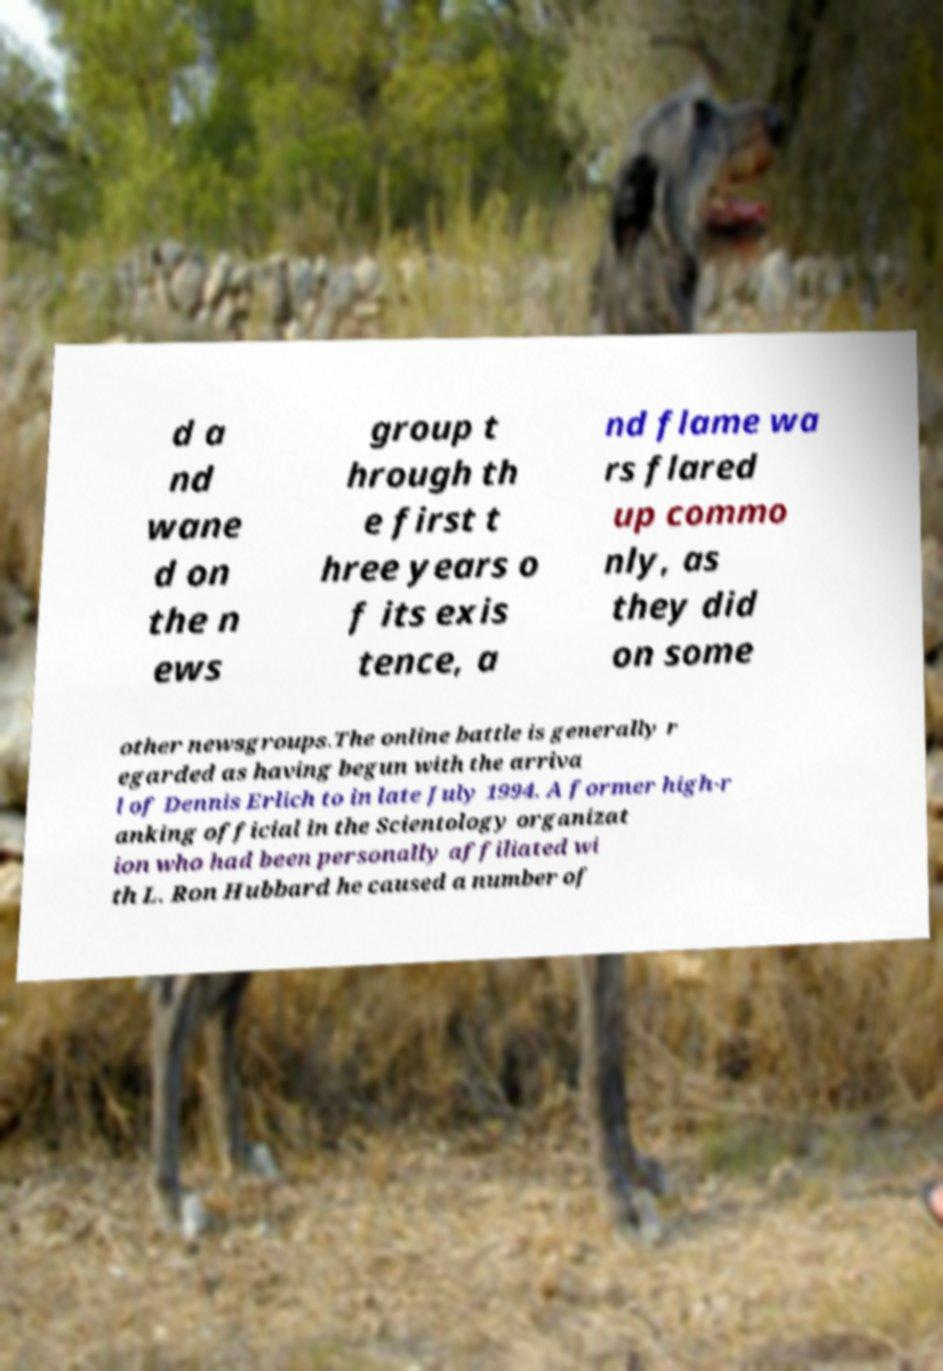Please identify and transcribe the text found in this image. d a nd wane d on the n ews group t hrough th e first t hree years o f its exis tence, a nd flame wa rs flared up commo nly, as they did on some other newsgroups.The online battle is generally r egarded as having begun with the arriva l of Dennis Erlich to in late July 1994. A former high-r anking official in the Scientology organizat ion who had been personally affiliated wi th L. Ron Hubbard he caused a number of 